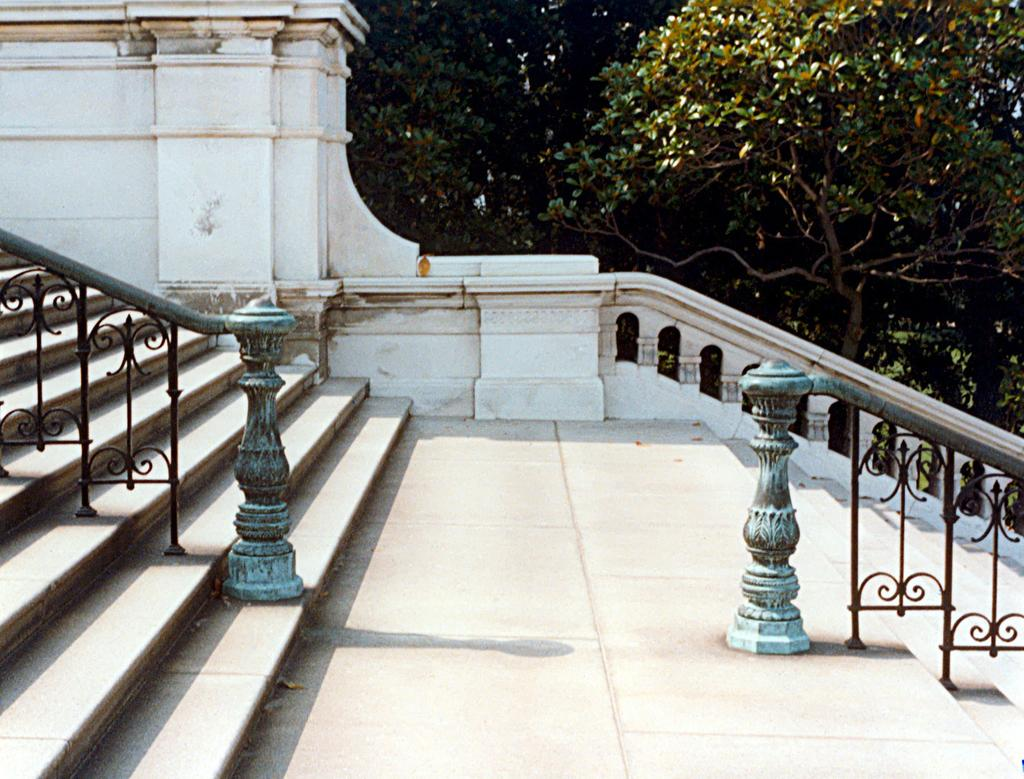What type of architectural feature is present in the image? There are stairs in the image. Are there any safety features associated with the stairs? Yes, there are railings in the image. What type of natural elements can be seen in the image? There are trees in the image. What color is the wall visible in the image? There is a white-colored wall in the image. What type of volcano can be seen erupting in the image? There is no volcano present in the image; it features stairs, railings, trees, and a white-colored wall. What kind of lunch is being served in the image? There is no lunch or food visible in the image. 